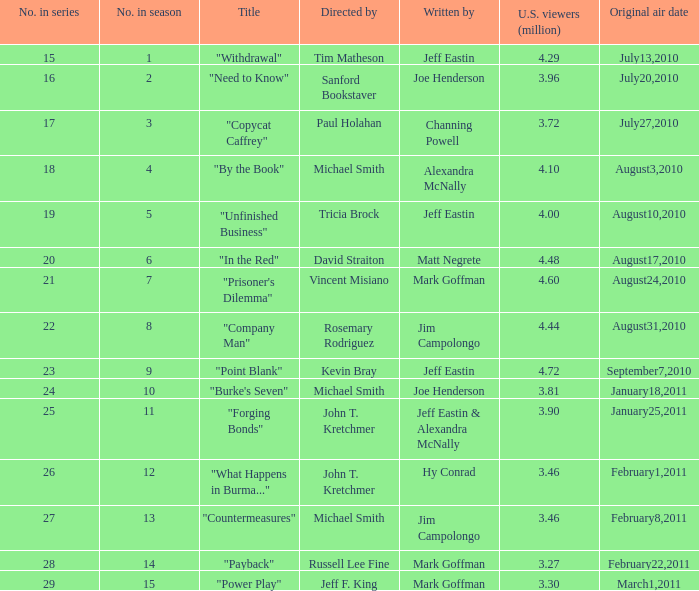How many millions of people in the US watched the "Company Man" episode? 4.44. 